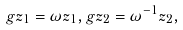Convert formula to latex. <formula><loc_0><loc_0><loc_500><loc_500>g z _ { 1 } = \omega z _ { 1 } , g z _ { 2 } = \omega ^ { - 1 } z _ { 2 } ,</formula> 